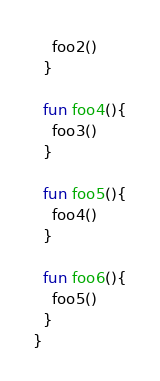<code> <loc_0><loc_0><loc_500><loc_500><_Kotlin_>    foo2()
  }

  fun foo4(){
    foo3()
  }

  fun foo5(){
    foo4()
  }

  fun foo6(){
    foo5()
  }
}</code> 